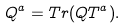<formula> <loc_0><loc_0><loc_500><loc_500>Q ^ { a } = T r ( Q T ^ { a } ) .</formula> 